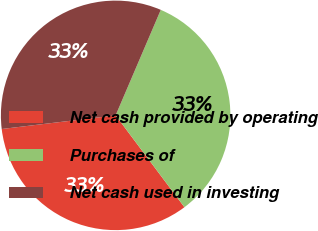Convert chart to OTSL. <chart><loc_0><loc_0><loc_500><loc_500><pie_chart><fcel>Net cash provided by operating<fcel>Purchases of<fcel>Net cash used in investing<nl><fcel>33.33%<fcel>33.33%<fcel>33.33%<nl></chart> 